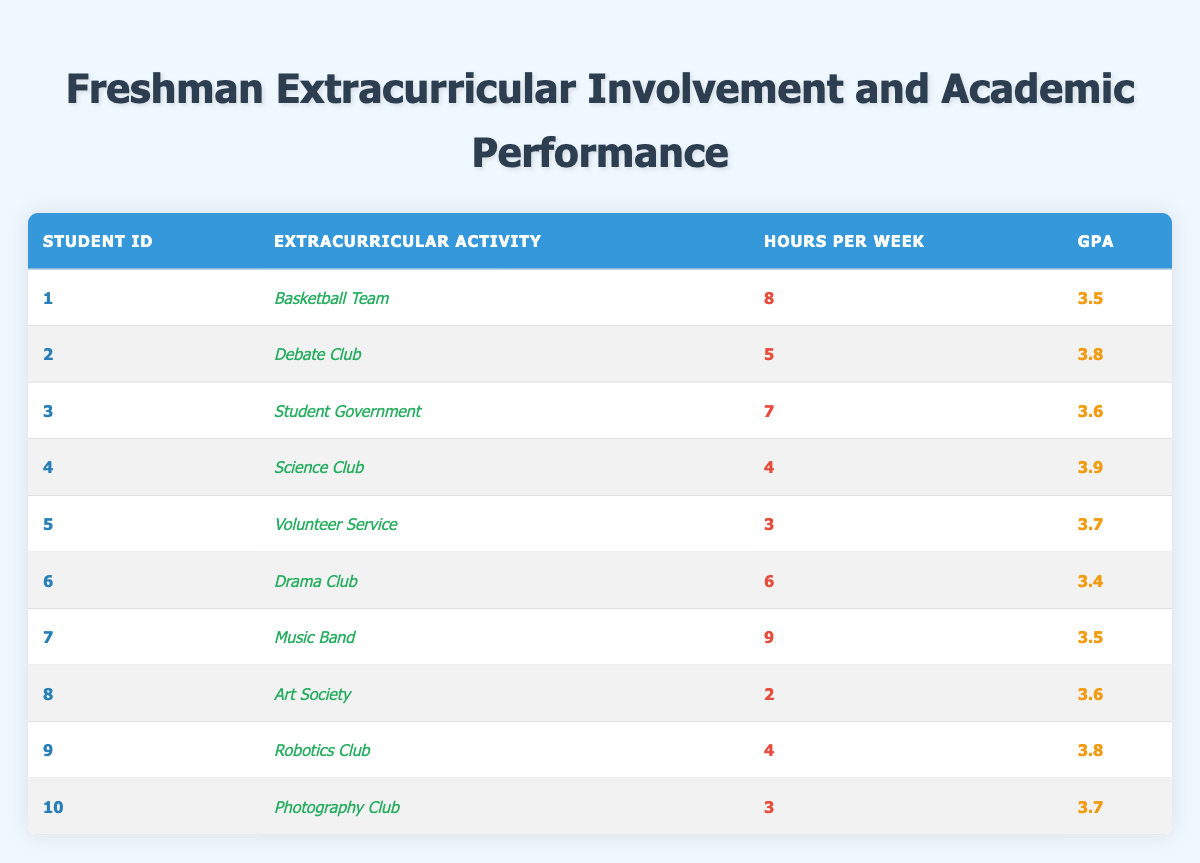What's the GPA of the student involved in the Debate Club? Referring to the table, the row for the Debate Club shows that the GPA for student ID 2 is 3.8
Answer: 3.8 How many hours per week does the student participating in the Science Club engage in extracurricular activities? The table indicates that the Science Club (student ID 4) requires 4 hours of involvement per week
Answer: 4 Which extracurricular activity has the highest GPA among participants? By examining the GPA values in the table, the highest GPA is 3.9 which is from the student engaged in the Science Club (student ID 4)
Answer: Science Club Is there a student with a GPA of 3.6 who spends more than 6 hours per week on extracurricular activities? Looking at the data, there are two students with a GPA of 3.6: one spends 7 hours (Student Government) and another spends 2 hours (Art Society). Since the Student Government spends more than 6 hours, the answer is yes
Answer: Yes What is the average GPA of students who are involved in extracurricular activities for at least 5 hours weekly? To calculate the average GPA, first identify the students who spend at least 5 hours weekly: Basketball Team (3.5), Debate Club (3.8), Student Government (3.6), Music Band (3.5), and Robotics Club (3.8). Thus, we sum up their GPAs: 3.5 + 3.8 + 3.6 + 3.5 + 3.8 = 18.2. There are 5 students, so the average GPA is 18.2 / 5 = 3.64
Answer: 3.64 